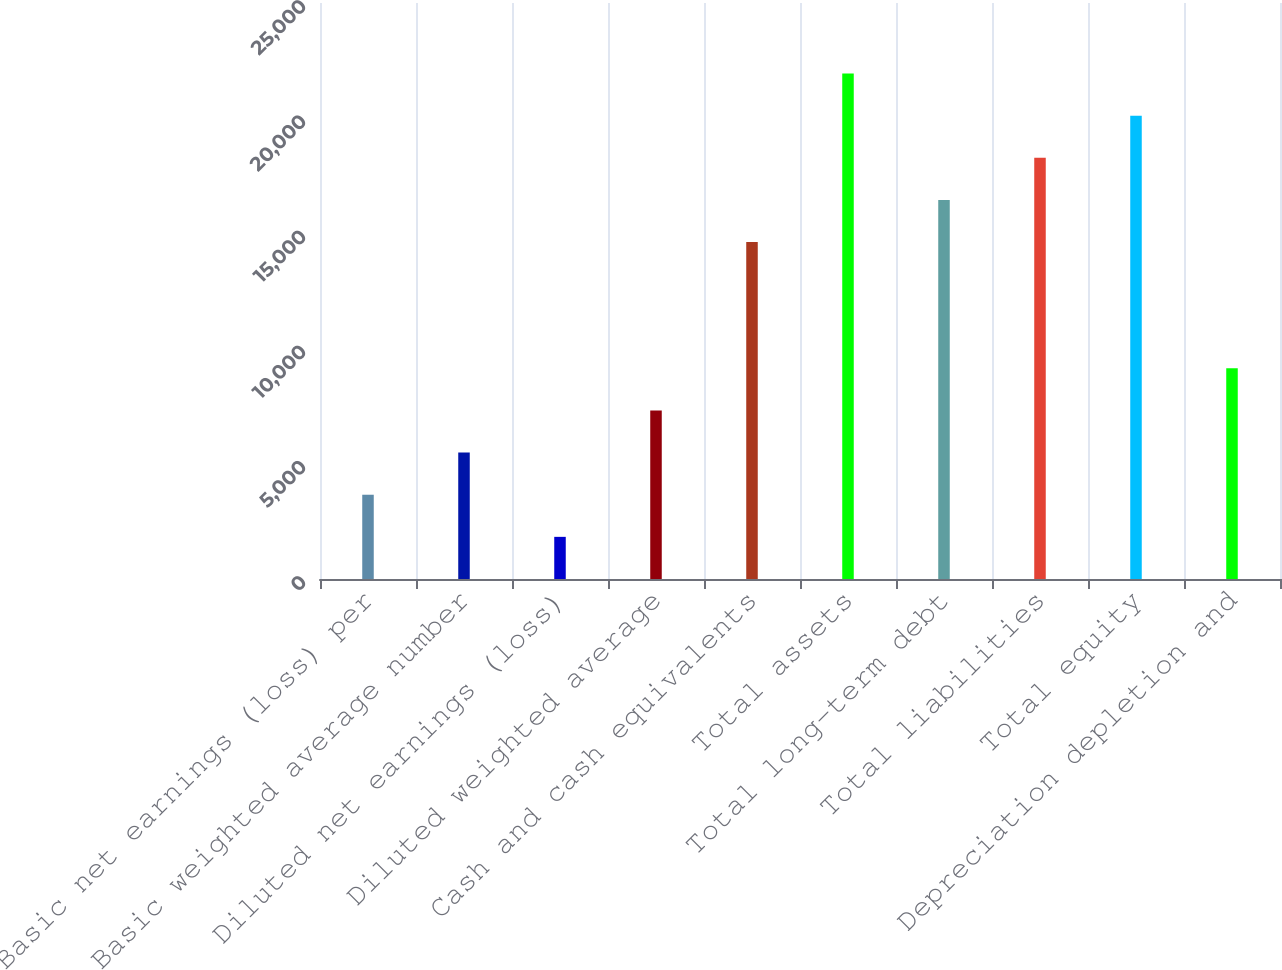Convert chart to OTSL. <chart><loc_0><loc_0><loc_500><loc_500><bar_chart><fcel>Basic net earnings (loss) per<fcel>Basic weighted average number<fcel>Diluted net earnings (loss)<fcel>Diluted weighted average<fcel>Cash and cash equivalents<fcel>Total assets<fcel>Total long-term debt<fcel>Total liabilities<fcel>Total equity<fcel>Depreciation depletion and<nl><fcel>3657.4<fcel>5485.6<fcel>1829.2<fcel>7313.8<fcel>14626.6<fcel>21939.4<fcel>16454.8<fcel>18283<fcel>20111.2<fcel>9142<nl></chart> 